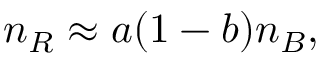Convert formula to latex. <formula><loc_0><loc_0><loc_500><loc_500>n _ { R } \approx a ( 1 - b ) n _ { B } ,</formula> 